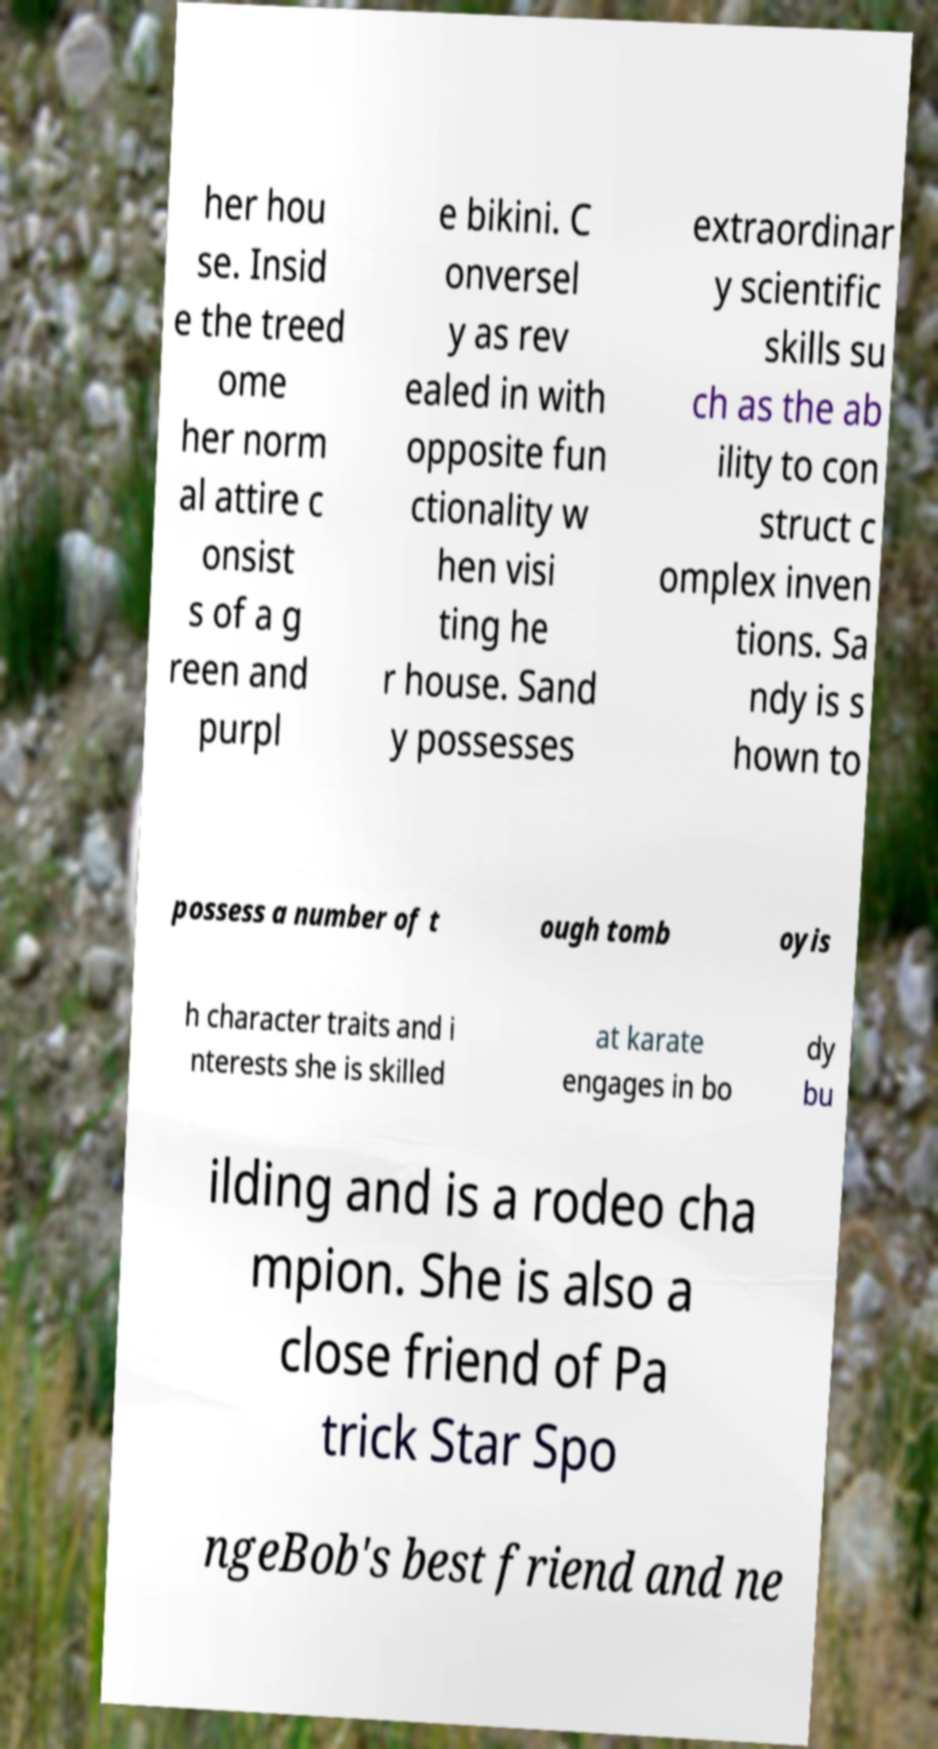For documentation purposes, I need the text within this image transcribed. Could you provide that? her hou se. Insid e the treed ome her norm al attire c onsist s of a g reen and purpl e bikini. C onversel y as rev ealed in with opposite fun ctionality w hen visi ting he r house. Sand y possesses extraordinar y scientific skills su ch as the ab ility to con struct c omplex inven tions. Sa ndy is s hown to possess a number of t ough tomb oyis h character traits and i nterests she is skilled at karate engages in bo dy bu ilding and is a rodeo cha mpion. She is also a close friend of Pa trick Star Spo ngeBob's best friend and ne 